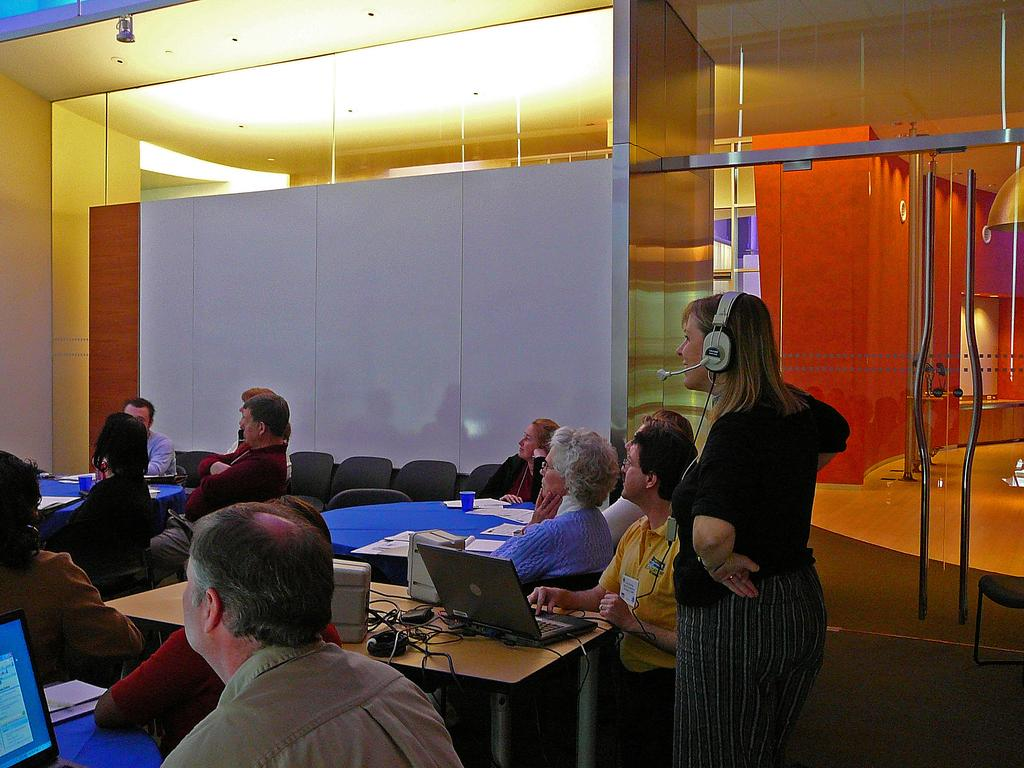How many people are sitting in the room? There are people sitting in the room, and they are sitting on chairs. What is on the table in the room? There are three laptops on the table in the room. What is the lady doing in front of the table? There is a lady standing in front of the table. What type of muscle is being exercised by the people sitting in the room? There is no indication in the image that the people are exercising any muscles; they are simply sitting on chairs. 